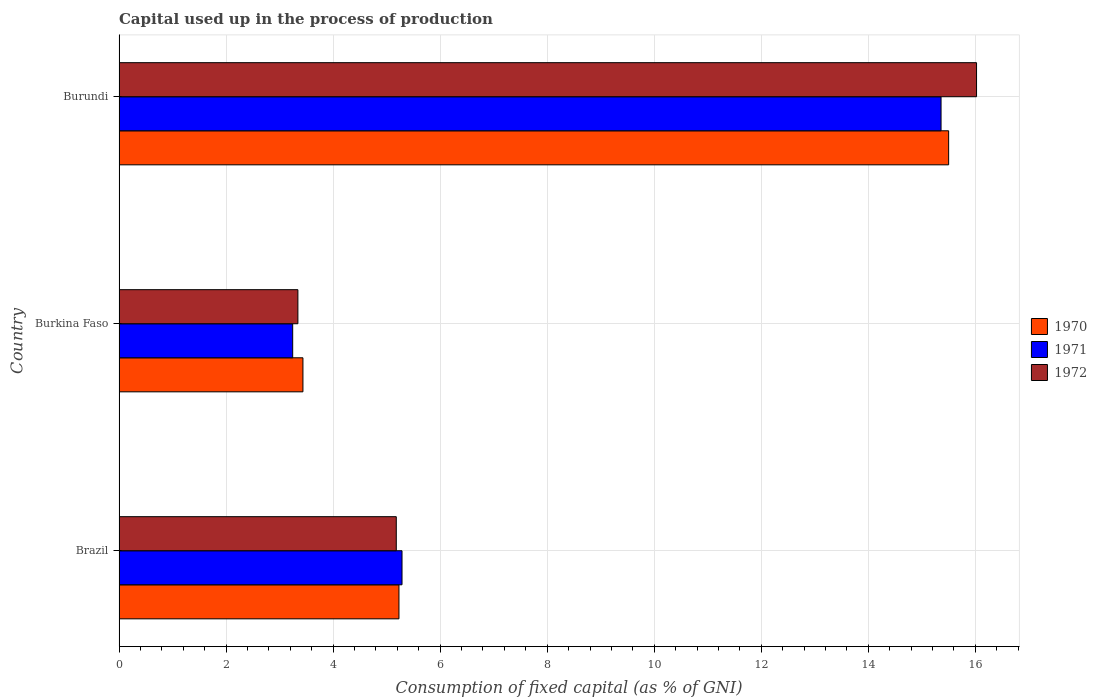How many different coloured bars are there?
Provide a succinct answer. 3. Are the number of bars per tick equal to the number of legend labels?
Provide a succinct answer. Yes. What is the label of the 1st group of bars from the top?
Ensure brevity in your answer.  Burundi. In how many cases, is the number of bars for a given country not equal to the number of legend labels?
Offer a terse response. 0. What is the capital used up in the process of production in 1972 in Brazil?
Provide a short and direct response. 5.18. Across all countries, what is the maximum capital used up in the process of production in 1972?
Offer a very short reply. 16.02. Across all countries, what is the minimum capital used up in the process of production in 1970?
Your answer should be compact. 3.44. In which country was the capital used up in the process of production in 1970 maximum?
Offer a very short reply. Burundi. In which country was the capital used up in the process of production in 1972 minimum?
Make the answer very short. Burkina Faso. What is the total capital used up in the process of production in 1970 in the graph?
Give a very brief answer. 24.17. What is the difference between the capital used up in the process of production in 1970 in Brazil and that in Burkina Faso?
Your answer should be very brief. 1.79. What is the difference between the capital used up in the process of production in 1970 in Burkina Faso and the capital used up in the process of production in 1971 in Brazil?
Your answer should be very brief. -1.85. What is the average capital used up in the process of production in 1971 per country?
Your answer should be very brief. 7.96. What is the difference between the capital used up in the process of production in 1971 and capital used up in the process of production in 1970 in Burkina Faso?
Your answer should be very brief. -0.19. In how many countries, is the capital used up in the process of production in 1970 greater than 4 %?
Provide a succinct answer. 2. What is the ratio of the capital used up in the process of production in 1970 in Brazil to that in Burkina Faso?
Your response must be concise. 1.52. Is the capital used up in the process of production in 1971 in Brazil less than that in Burkina Faso?
Ensure brevity in your answer.  No. Is the difference between the capital used up in the process of production in 1971 in Burkina Faso and Burundi greater than the difference between the capital used up in the process of production in 1970 in Burkina Faso and Burundi?
Provide a short and direct response. No. What is the difference between the highest and the second highest capital used up in the process of production in 1972?
Provide a short and direct response. 10.84. What is the difference between the highest and the lowest capital used up in the process of production in 1971?
Keep it short and to the point. 12.11. Are all the bars in the graph horizontal?
Offer a very short reply. Yes. How many countries are there in the graph?
Make the answer very short. 3. What is the difference between two consecutive major ticks on the X-axis?
Provide a succinct answer. 2. Does the graph contain any zero values?
Ensure brevity in your answer.  No. Does the graph contain grids?
Keep it short and to the point. Yes. Where does the legend appear in the graph?
Provide a short and direct response. Center right. How many legend labels are there?
Your answer should be compact. 3. How are the legend labels stacked?
Offer a terse response. Vertical. What is the title of the graph?
Make the answer very short. Capital used up in the process of production. What is the label or title of the X-axis?
Provide a short and direct response. Consumption of fixed capital (as % of GNI). What is the Consumption of fixed capital (as % of GNI) of 1970 in Brazil?
Offer a terse response. 5.23. What is the Consumption of fixed capital (as % of GNI) in 1971 in Brazil?
Make the answer very short. 5.29. What is the Consumption of fixed capital (as % of GNI) in 1972 in Brazil?
Keep it short and to the point. 5.18. What is the Consumption of fixed capital (as % of GNI) in 1970 in Burkina Faso?
Your answer should be very brief. 3.44. What is the Consumption of fixed capital (as % of GNI) in 1971 in Burkina Faso?
Provide a short and direct response. 3.24. What is the Consumption of fixed capital (as % of GNI) of 1972 in Burkina Faso?
Keep it short and to the point. 3.34. What is the Consumption of fixed capital (as % of GNI) in 1970 in Burundi?
Keep it short and to the point. 15.5. What is the Consumption of fixed capital (as % of GNI) of 1971 in Burundi?
Offer a terse response. 15.36. What is the Consumption of fixed capital (as % of GNI) of 1972 in Burundi?
Your answer should be compact. 16.02. Across all countries, what is the maximum Consumption of fixed capital (as % of GNI) in 1970?
Ensure brevity in your answer.  15.5. Across all countries, what is the maximum Consumption of fixed capital (as % of GNI) of 1971?
Provide a succinct answer. 15.36. Across all countries, what is the maximum Consumption of fixed capital (as % of GNI) in 1972?
Provide a short and direct response. 16.02. Across all countries, what is the minimum Consumption of fixed capital (as % of GNI) in 1970?
Offer a very short reply. 3.44. Across all countries, what is the minimum Consumption of fixed capital (as % of GNI) in 1971?
Ensure brevity in your answer.  3.24. Across all countries, what is the minimum Consumption of fixed capital (as % of GNI) of 1972?
Provide a succinct answer. 3.34. What is the total Consumption of fixed capital (as % of GNI) of 1970 in the graph?
Your answer should be very brief. 24.17. What is the total Consumption of fixed capital (as % of GNI) in 1971 in the graph?
Make the answer very short. 23.89. What is the total Consumption of fixed capital (as % of GNI) of 1972 in the graph?
Give a very brief answer. 24.54. What is the difference between the Consumption of fixed capital (as % of GNI) of 1970 in Brazil and that in Burkina Faso?
Provide a short and direct response. 1.79. What is the difference between the Consumption of fixed capital (as % of GNI) in 1971 in Brazil and that in Burkina Faso?
Give a very brief answer. 2.04. What is the difference between the Consumption of fixed capital (as % of GNI) in 1972 in Brazil and that in Burkina Faso?
Keep it short and to the point. 1.84. What is the difference between the Consumption of fixed capital (as % of GNI) of 1970 in Brazil and that in Burundi?
Your response must be concise. -10.27. What is the difference between the Consumption of fixed capital (as % of GNI) of 1971 in Brazil and that in Burundi?
Offer a very short reply. -10.07. What is the difference between the Consumption of fixed capital (as % of GNI) in 1972 in Brazil and that in Burundi?
Ensure brevity in your answer.  -10.84. What is the difference between the Consumption of fixed capital (as % of GNI) in 1970 in Burkina Faso and that in Burundi?
Your answer should be compact. -12.06. What is the difference between the Consumption of fixed capital (as % of GNI) in 1971 in Burkina Faso and that in Burundi?
Ensure brevity in your answer.  -12.11. What is the difference between the Consumption of fixed capital (as % of GNI) in 1972 in Burkina Faso and that in Burundi?
Make the answer very short. -12.68. What is the difference between the Consumption of fixed capital (as % of GNI) of 1970 in Brazil and the Consumption of fixed capital (as % of GNI) of 1971 in Burkina Faso?
Offer a terse response. 1.99. What is the difference between the Consumption of fixed capital (as % of GNI) in 1970 in Brazil and the Consumption of fixed capital (as % of GNI) in 1972 in Burkina Faso?
Make the answer very short. 1.89. What is the difference between the Consumption of fixed capital (as % of GNI) in 1971 in Brazil and the Consumption of fixed capital (as % of GNI) in 1972 in Burkina Faso?
Give a very brief answer. 1.95. What is the difference between the Consumption of fixed capital (as % of GNI) of 1970 in Brazil and the Consumption of fixed capital (as % of GNI) of 1971 in Burundi?
Keep it short and to the point. -10.13. What is the difference between the Consumption of fixed capital (as % of GNI) in 1970 in Brazil and the Consumption of fixed capital (as % of GNI) in 1972 in Burundi?
Offer a very short reply. -10.79. What is the difference between the Consumption of fixed capital (as % of GNI) in 1971 in Brazil and the Consumption of fixed capital (as % of GNI) in 1972 in Burundi?
Offer a very short reply. -10.74. What is the difference between the Consumption of fixed capital (as % of GNI) in 1970 in Burkina Faso and the Consumption of fixed capital (as % of GNI) in 1971 in Burundi?
Offer a terse response. -11.92. What is the difference between the Consumption of fixed capital (as % of GNI) in 1970 in Burkina Faso and the Consumption of fixed capital (as % of GNI) in 1972 in Burundi?
Offer a very short reply. -12.59. What is the difference between the Consumption of fixed capital (as % of GNI) of 1971 in Burkina Faso and the Consumption of fixed capital (as % of GNI) of 1972 in Burundi?
Provide a short and direct response. -12.78. What is the average Consumption of fixed capital (as % of GNI) in 1970 per country?
Keep it short and to the point. 8.06. What is the average Consumption of fixed capital (as % of GNI) in 1971 per country?
Ensure brevity in your answer.  7.96. What is the average Consumption of fixed capital (as % of GNI) in 1972 per country?
Give a very brief answer. 8.18. What is the difference between the Consumption of fixed capital (as % of GNI) in 1970 and Consumption of fixed capital (as % of GNI) in 1971 in Brazil?
Ensure brevity in your answer.  -0.06. What is the difference between the Consumption of fixed capital (as % of GNI) of 1970 and Consumption of fixed capital (as % of GNI) of 1972 in Brazil?
Offer a very short reply. 0.05. What is the difference between the Consumption of fixed capital (as % of GNI) of 1971 and Consumption of fixed capital (as % of GNI) of 1972 in Brazil?
Your answer should be compact. 0.11. What is the difference between the Consumption of fixed capital (as % of GNI) of 1970 and Consumption of fixed capital (as % of GNI) of 1971 in Burkina Faso?
Provide a short and direct response. 0.19. What is the difference between the Consumption of fixed capital (as % of GNI) of 1970 and Consumption of fixed capital (as % of GNI) of 1972 in Burkina Faso?
Provide a succinct answer. 0.09. What is the difference between the Consumption of fixed capital (as % of GNI) of 1971 and Consumption of fixed capital (as % of GNI) of 1972 in Burkina Faso?
Your answer should be very brief. -0.1. What is the difference between the Consumption of fixed capital (as % of GNI) in 1970 and Consumption of fixed capital (as % of GNI) in 1971 in Burundi?
Your answer should be very brief. 0.14. What is the difference between the Consumption of fixed capital (as % of GNI) in 1970 and Consumption of fixed capital (as % of GNI) in 1972 in Burundi?
Offer a terse response. -0.52. What is the difference between the Consumption of fixed capital (as % of GNI) of 1971 and Consumption of fixed capital (as % of GNI) of 1972 in Burundi?
Provide a succinct answer. -0.66. What is the ratio of the Consumption of fixed capital (as % of GNI) in 1970 in Brazil to that in Burkina Faso?
Offer a terse response. 1.52. What is the ratio of the Consumption of fixed capital (as % of GNI) in 1971 in Brazil to that in Burkina Faso?
Provide a short and direct response. 1.63. What is the ratio of the Consumption of fixed capital (as % of GNI) in 1972 in Brazil to that in Burkina Faso?
Your answer should be very brief. 1.55. What is the ratio of the Consumption of fixed capital (as % of GNI) of 1970 in Brazil to that in Burundi?
Ensure brevity in your answer.  0.34. What is the ratio of the Consumption of fixed capital (as % of GNI) in 1971 in Brazil to that in Burundi?
Your answer should be very brief. 0.34. What is the ratio of the Consumption of fixed capital (as % of GNI) of 1972 in Brazil to that in Burundi?
Your response must be concise. 0.32. What is the ratio of the Consumption of fixed capital (as % of GNI) in 1970 in Burkina Faso to that in Burundi?
Make the answer very short. 0.22. What is the ratio of the Consumption of fixed capital (as % of GNI) in 1971 in Burkina Faso to that in Burundi?
Your response must be concise. 0.21. What is the ratio of the Consumption of fixed capital (as % of GNI) in 1972 in Burkina Faso to that in Burundi?
Your answer should be compact. 0.21. What is the difference between the highest and the second highest Consumption of fixed capital (as % of GNI) of 1970?
Offer a very short reply. 10.27. What is the difference between the highest and the second highest Consumption of fixed capital (as % of GNI) of 1971?
Give a very brief answer. 10.07. What is the difference between the highest and the second highest Consumption of fixed capital (as % of GNI) in 1972?
Your response must be concise. 10.84. What is the difference between the highest and the lowest Consumption of fixed capital (as % of GNI) in 1970?
Offer a very short reply. 12.06. What is the difference between the highest and the lowest Consumption of fixed capital (as % of GNI) in 1971?
Your response must be concise. 12.11. What is the difference between the highest and the lowest Consumption of fixed capital (as % of GNI) of 1972?
Keep it short and to the point. 12.68. 